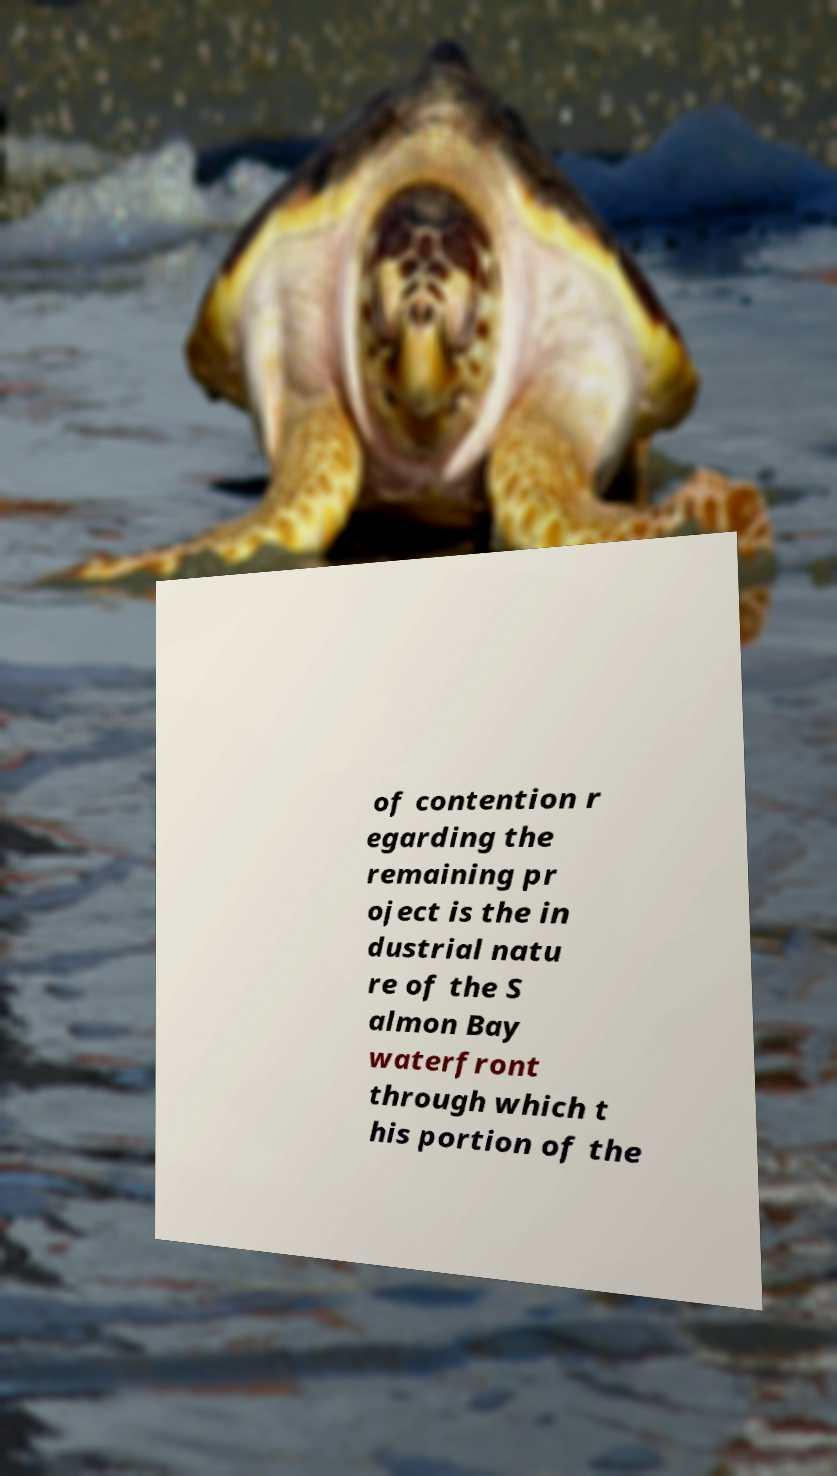Could you assist in decoding the text presented in this image and type it out clearly? of contention r egarding the remaining pr oject is the in dustrial natu re of the S almon Bay waterfront through which t his portion of the 